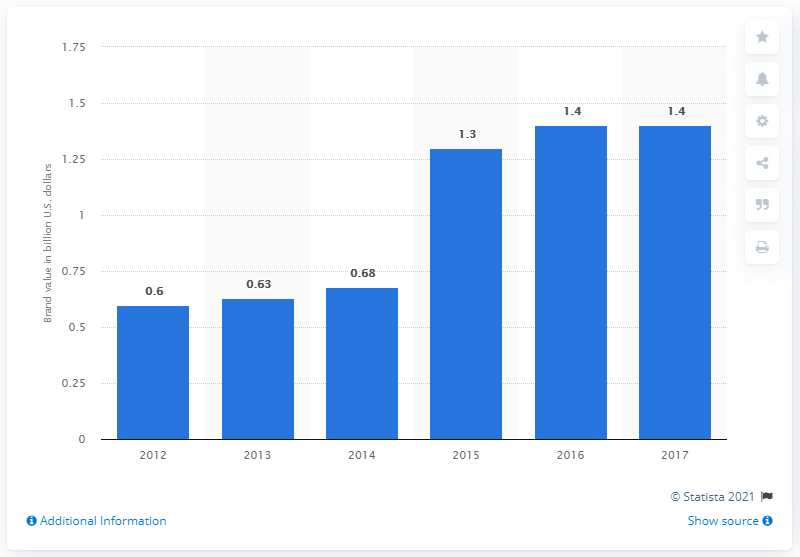Give some essential details in this illustration. In 2017, the brand value of YES was estimated to be approximately 1.4 billion dollars. 